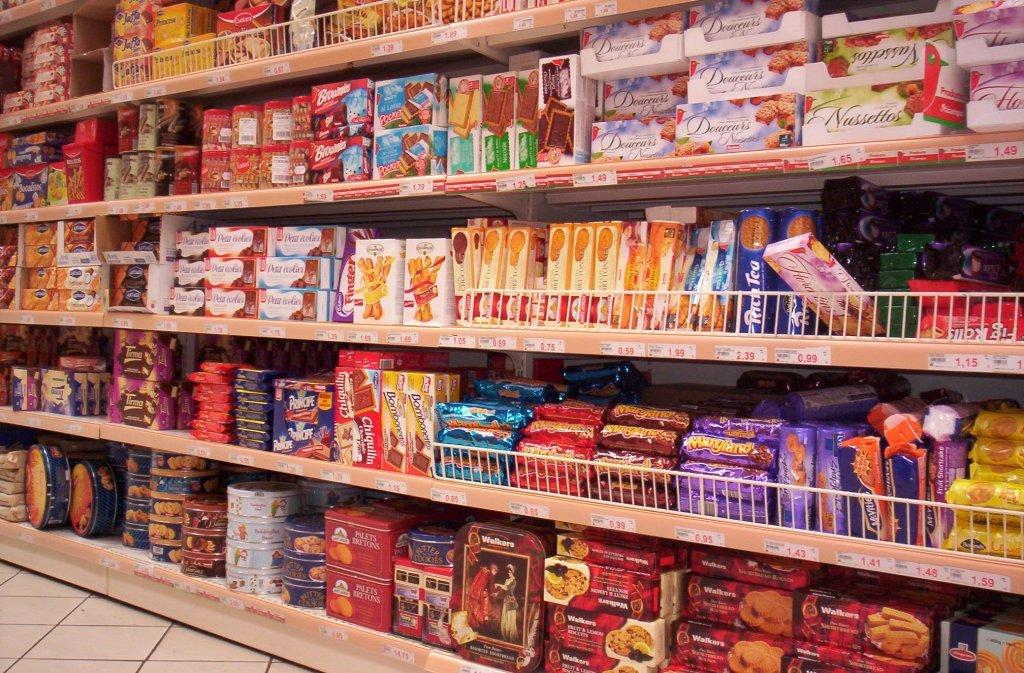What types of containers are visible in the image? There are boxes and jars in the image. Where are the objects in the image stored or displayed? The objects are in racks in the image. What type of camp can be seen in the image? There is no camp present in the image; it features boxes, jars, and objects in racks. What kind of alley is visible in the image? There is no alley present in the image; it features boxes, jars, and objects in racks. 